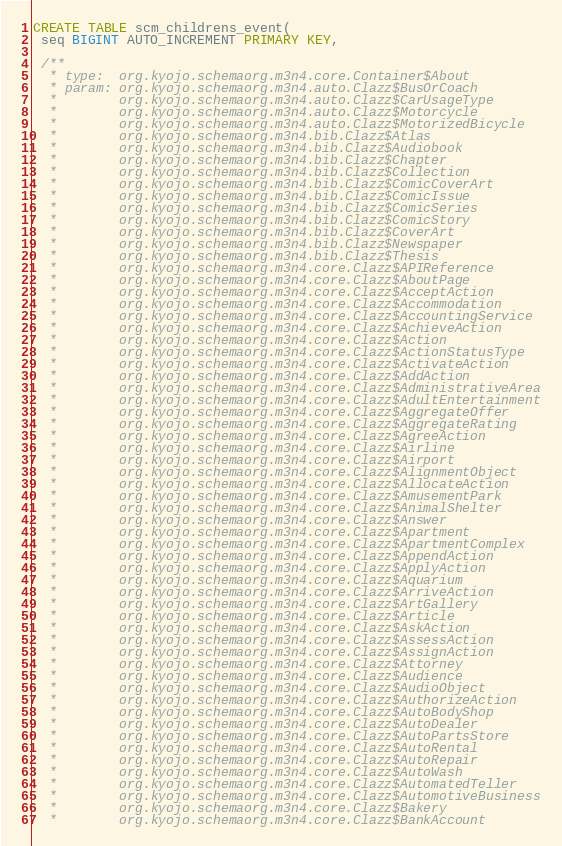Convert code to text. <code><loc_0><loc_0><loc_500><loc_500><_SQL_>CREATE TABLE scm_childrens_event(
 seq BIGINT AUTO_INCREMENT PRIMARY KEY,

 /**
  * type:  org.kyojo.schemaorg.m3n4.core.Container$About
  * param: org.kyojo.schemaorg.m3n4.auto.Clazz$BusOrCoach
  *        org.kyojo.schemaorg.m3n4.auto.Clazz$CarUsageType
  *        org.kyojo.schemaorg.m3n4.auto.Clazz$Motorcycle
  *        org.kyojo.schemaorg.m3n4.auto.Clazz$MotorizedBicycle
  *        org.kyojo.schemaorg.m3n4.bib.Clazz$Atlas
  *        org.kyojo.schemaorg.m3n4.bib.Clazz$Audiobook
  *        org.kyojo.schemaorg.m3n4.bib.Clazz$Chapter
  *        org.kyojo.schemaorg.m3n4.bib.Clazz$Collection
  *        org.kyojo.schemaorg.m3n4.bib.Clazz$ComicCoverArt
  *        org.kyojo.schemaorg.m3n4.bib.Clazz$ComicIssue
  *        org.kyojo.schemaorg.m3n4.bib.Clazz$ComicSeries
  *        org.kyojo.schemaorg.m3n4.bib.Clazz$ComicStory
  *        org.kyojo.schemaorg.m3n4.bib.Clazz$CoverArt
  *        org.kyojo.schemaorg.m3n4.bib.Clazz$Newspaper
  *        org.kyojo.schemaorg.m3n4.bib.Clazz$Thesis
  *        org.kyojo.schemaorg.m3n4.core.Clazz$APIReference
  *        org.kyojo.schemaorg.m3n4.core.Clazz$AboutPage
  *        org.kyojo.schemaorg.m3n4.core.Clazz$AcceptAction
  *        org.kyojo.schemaorg.m3n4.core.Clazz$Accommodation
  *        org.kyojo.schemaorg.m3n4.core.Clazz$AccountingService
  *        org.kyojo.schemaorg.m3n4.core.Clazz$AchieveAction
  *        org.kyojo.schemaorg.m3n4.core.Clazz$Action
  *        org.kyojo.schemaorg.m3n4.core.Clazz$ActionStatusType
  *        org.kyojo.schemaorg.m3n4.core.Clazz$ActivateAction
  *        org.kyojo.schemaorg.m3n4.core.Clazz$AddAction
  *        org.kyojo.schemaorg.m3n4.core.Clazz$AdministrativeArea
  *        org.kyojo.schemaorg.m3n4.core.Clazz$AdultEntertainment
  *        org.kyojo.schemaorg.m3n4.core.Clazz$AggregateOffer
  *        org.kyojo.schemaorg.m3n4.core.Clazz$AggregateRating
  *        org.kyojo.schemaorg.m3n4.core.Clazz$AgreeAction
  *        org.kyojo.schemaorg.m3n4.core.Clazz$Airline
  *        org.kyojo.schemaorg.m3n4.core.Clazz$Airport
  *        org.kyojo.schemaorg.m3n4.core.Clazz$AlignmentObject
  *        org.kyojo.schemaorg.m3n4.core.Clazz$AllocateAction
  *        org.kyojo.schemaorg.m3n4.core.Clazz$AmusementPark
  *        org.kyojo.schemaorg.m3n4.core.Clazz$AnimalShelter
  *        org.kyojo.schemaorg.m3n4.core.Clazz$Answer
  *        org.kyojo.schemaorg.m3n4.core.Clazz$Apartment
  *        org.kyojo.schemaorg.m3n4.core.Clazz$ApartmentComplex
  *        org.kyojo.schemaorg.m3n4.core.Clazz$AppendAction
  *        org.kyojo.schemaorg.m3n4.core.Clazz$ApplyAction
  *        org.kyojo.schemaorg.m3n4.core.Clazz$Aquarium
  *        org.kyojo.schemaorg.m3n4.core.Clazz$ArriveAction
  *        org.kyojo.schemaorg.m3n4.core.Clazz$ArtGallery
  *        org.kyojo.schemaorg.m3n4.core.Clazz$Article
  *        org.kyojo.schemaorg.m3n4.core.Clazz$AskAction
  *        org.kyojo.schemaorg.m3n4.core.Clazz$AssessAction
  *        org.kyojo.schemaorg.m3n4.core.Clazz$AssignAction
  *        org.kyojo.schemaorg.m3n4.core.Clazz$Attorney
  *        org.kyojo.schemaorg.m3n4.core.Clazz$Audience
  *        org.kyojo.schemaorg.m3n4.core.Clazz$AudioObject
  *        org.kyojo.schemaorg.m3n4.core.Clazz$AuthorizeAction
  *        org.kyojo.schemaorg.m3n4.core.Clazz$AutoBodyShop
  *        org.kyojo.schemaorg.m3n4.core.Clazz$AutoDealer
  *        org.kyojo.schemaorg.m3n4.core.Clazz$AutoPartsStore
  *        org.kyojo.schemaorg.m3n4.core.Clazz$AutoRental
  *        org.kyojo.schemaorg.m3n4.core.Clazz$AutoRepair
  *        org.kyojo.schemaorg.m3n4.core.Clazz$AutoWash
  *        org.kyojo.schemaorg.m3n4.core.Clazz$AutomatedTeller
  *        org.kyojo.schemaorg.m3n4.core.Clazz$AutomotiveBusiness
  *        org.kyojo.schemaorg.m3n4.core.Clazz$Bakery
  *        org.kyojo.schemaorg.m3n4.core.Clazz$BankAccount</code> 